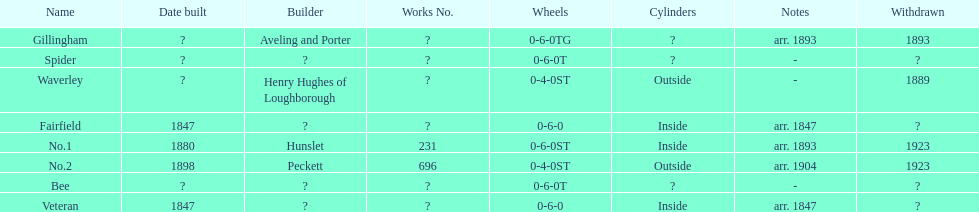How long after fairfield was no. 1 built? 33 years. 